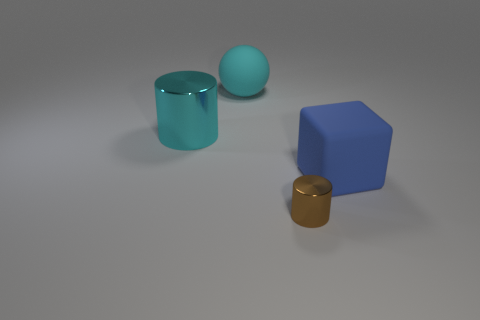Add 4 large cyan rubber spheres. How many objects exist? 8 Subtract all spheres. How many objects are left? 3 Add 1 metal cylinders. How many metal cylinders are left? 3 Add 4 cyan spheres. How many cyan spheres exist? 5 Subtract 0 red cylinders. How many objects are left? 4 Subtract all tiny red matte objects. Subtract all tiny brown shiny cylinders. How many objects are left? 3 